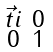<formula> <loc_0><loc_0><loc_500><loc_500>\begin{smallmatrix} \vec { t } i & 0 \\ 0 & 1 \end{smallmatrix}</formula> 